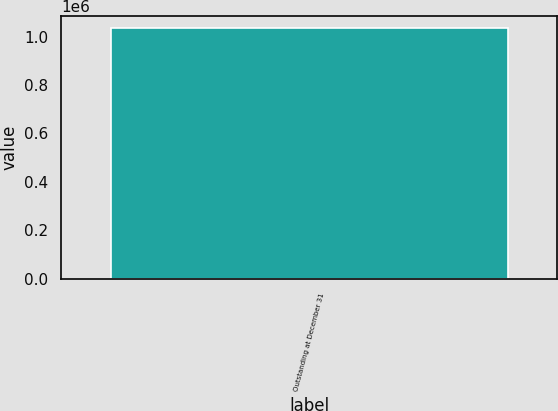Convert chart to OTSL. <chart><loc_0><loc_0><loc_500><loc_500><bar_chart><fcel>Outstanding at December 31<nl><fcel>1.03414e+06<nl></chart> 